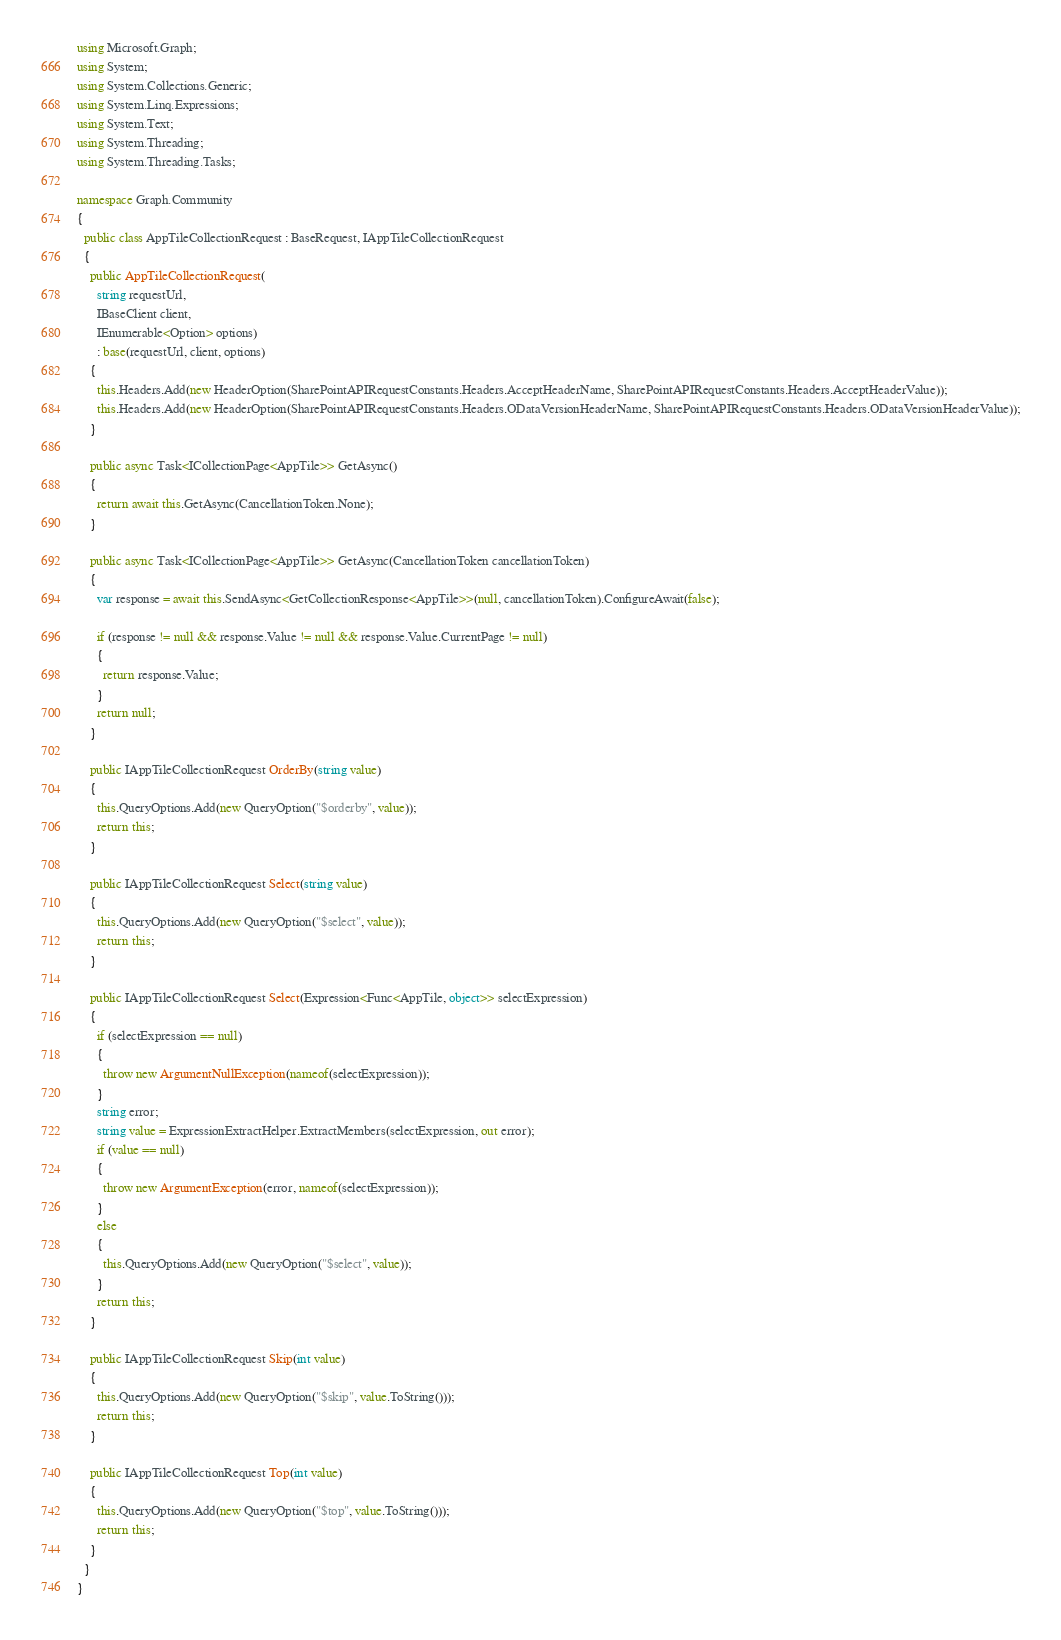<code> <loc_0><loc_0><loc_500><loc_500><_C#_>using Microsoft.Graph;
using System;
using System.Collections.Generic;
using System.Linq.Expressions;
using System.Text;
using System.Threading;
using System.Threading.Tasks;

namespace Graph.Community
{
  public class AppTileCollectionRequest : BaseRequest, IAppTileCollectionRequest
  {
    public AppTileCollectionRequest(
      string requestUrl,
      IBaseClient client,
      IEnumerable<Option> options)
      : base(requestUrl, client, options)
    {
      this.Headers.Add(new HeaderOption(SharePointAPIRequestConstants.Headers.AcceptHeaderName, SharePointAPIRequestConstants.Headers.AcceptHeaderValue));
      this.Headers.Add(new HeaderOption(SharePointAPIRequestConstants.Headers.ODataVersionHeaderName, SharePointAPIRequestConstants.Headers.ODataVersionHeaderValue));
    }

    public async Task<ICollectionPage<AppTile>> GetAsync()
    {
      return await this.GetAsync(CancellationToken.None);
    }

    public async Task<ICollectionPage<AppTile>> GetAsync(CancellationToken cancellationToken)
    {
      var response = await this.SendAsync<GetCollectionResponse<AppTile>>(null, cancellationToken).ConfigureAwait(false);

      if (response != null && response.Value != null && response.Value.CurrentPage != null)
      {
        return response.Value;
      }
      return null;
    }

    public IAppTileCollectionRequest OrderBy(string value)
    {
      this.QueryOptions.Add(new QueryOption("$orderby", value));
      return this;
    }

    public IAppTileCollectionRequest Select(string value)
    {
      this.QueryOptions.Add(new QueryOption("$select", value));
      return this;
    }

    public IAppTileCollectionRequest Select(Expression<Func<AppTile, object>> selectExpression)
    {
      if (selectExpression == null)
      {
        throw new ArgumentNullException(nameof(selectExpression));
      }
      string error;
      string value = ExpressionExtractHelper.ExtractMembers(selectExpression, out error);
      if (value == null)
      {
        throw new ArgumentException(error, nameof(selectExpression));
      }
      else
      {
        this.QueryOptions.Add(new QueryOption("$select", value));
      }
      return this;
    }

    public IAppTileCollectionRequest Skip(int value)
    {
      this.QueryOptions.Add(new QueryOption("$skip", value.ToString()));
      return this;
    }

    public IAppTileCollectionRequest Top(int value)
    {
      this.QueryOptions.Add(new QueryOption("$top", value.ToString()));
      return this;
    }
  }
}
</code> 